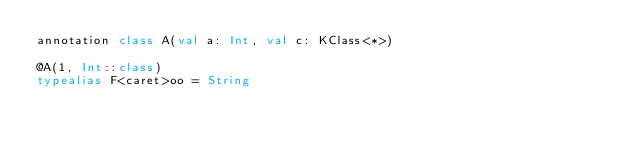<code> <loc_0><loc_0><loc_500><loc_500><_Kotlin_>annotation class A(val a: Int, val c: KClass<*>)

@A(1, Int::class)
typealias F<caret>oo = String</code> 